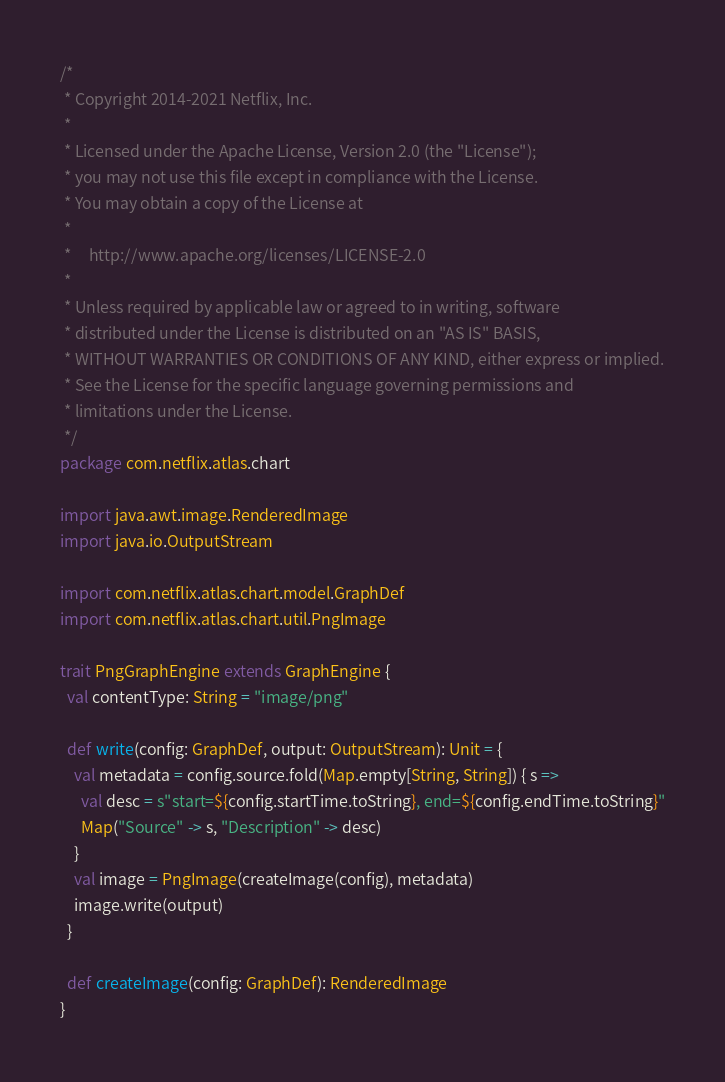<code> <loc_0><loc_0><loc_500><loc_500><_Scala_>/*
 * Copyright 2014-2021 Netflix, Inc.
 *
 * Licensed under the Apache License, Version 2.0 (the "License");
 * you may not use this file except in compliance with the License.
 * You may obtain a copy of the License at
 *
 *     http://www.apache.org/licenses/LICENSE-2.0
 *
 * Unless required by applicable law or agreed to in writing, software
 * distributed under the License is distributed on an "AS IS" BASIS,
 * WITHOUT WARRANTIES OR CONDITIONS OF ANY KIND, either express or implied.
 * See the License for the specific language governing permissions and
 * limitations under the License.
 */
package com.netflix.atlas.chart

import java.awt.image.RenderedImage
import java.io.OutputStream

import com.netflix.atlas.chart.model.GraphDef
import com.netflix.atlas.chart.util.PngImage

trait PngGraphEngine extends GraphEngine {
  val contentType: String = "image/png"

  def write(config: GraphDef, output: OutputStream): Unit = {
    val metadata = config.source.fold(Map.empty[String, String]) { s =>
      val desc = s"start=${config.startTime.toString}, end=${config.endTime.toString}"
      Map("Source" -> s, "Description" -> desc)
    }
    val image = PngImage(createImage(config), metadata)
    image.write(output)
  }

  def createImage(config: GraphDef): RenderedImage
}
</code> 